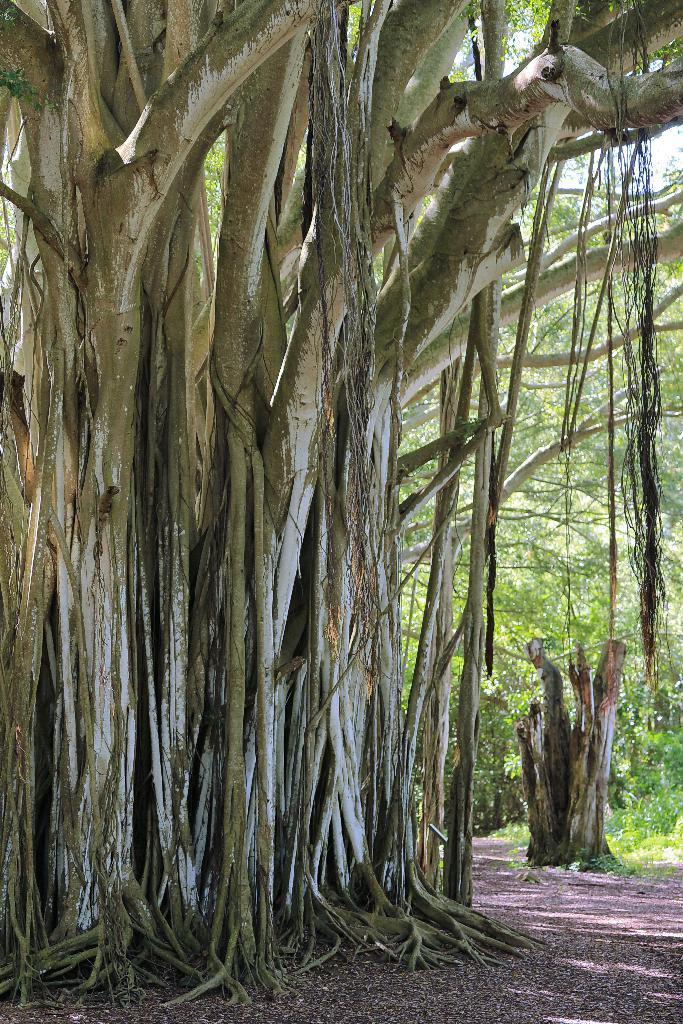Please provide a concise description of this image. In the foreground of this image, there is a tree trunk and roots hanging. In the background, there is another trunk and the trees. 